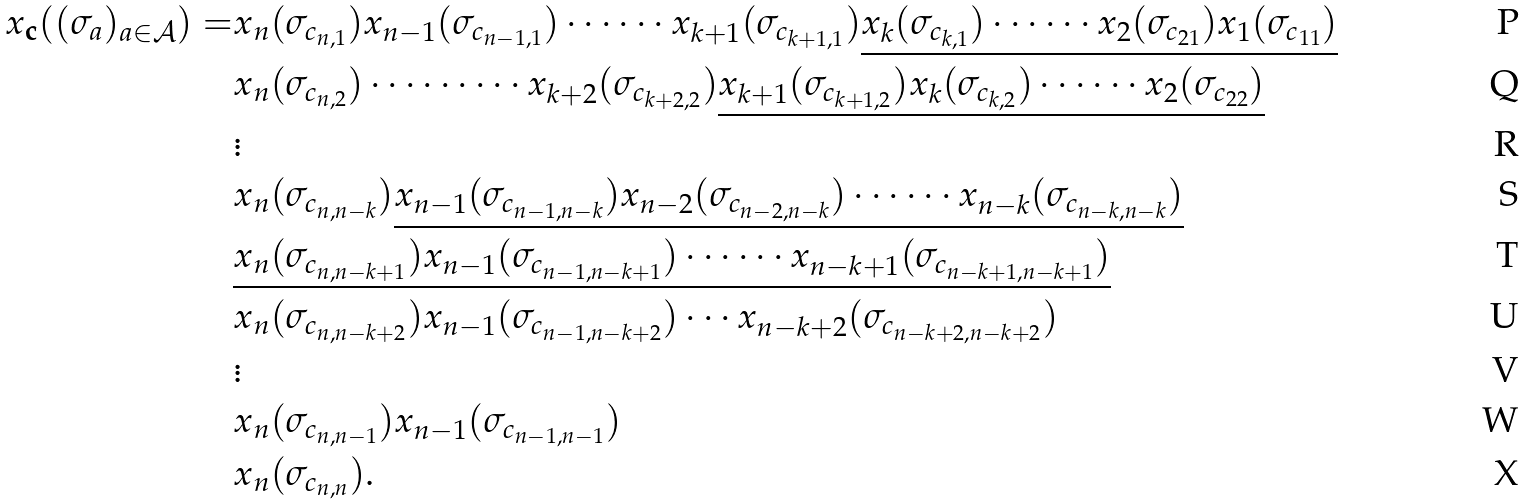<formula> <loc_0><loc_0><loc_500><loc_500>x _ { \mathbf c } ( ( \sigma _ { a } ) _ { a \in \mathcal { A } } ) = & x _ { n } ( \sigma _ { c _ { n , 1 } } ) x _ { n - 1 } ( \sigma _ { c _ { n - 1 , 1 } } ) \cdots \cdots x _ { k + 1 } ( \sigma _ { c _ { k + 1 , 1 } } ) \underline { x _ { k } ( \sigma _ { c _ { k , 1 } } ) \cdots \cdots x _ { 2 } ( \sigma _ { c _ { 2 1 } } ) x _ { 1 } ( \sigma _ { c _ { 1 1 } } ) } \\ & x _ { n } ( \sigma _ { c _ { n , 2 } } ) \cdots \cdots \cdots x _ { k + 2 } ( \sigma _ { c _ { k + 2 , 2 } } ) \underline { x _ { k + 1 } ( \sigma _ { c _ { k + 1 , 2 } } ) x _ { k } ( \sigma _ { c _ { k , 2 } } ) \cdots \cdots x _ { 2 } ( \sigma _ { c _ { 2 2 } } ) } \\ & \vdots \\ & x _ { n } ( \sigma _ { c _ { n , n - k } } ) \underline { x _ { n - 1 } ( \sigma _ { c _ { n - 1 , n - k } } ) x _ { n - 2 } ( \sigma _ { c _ { n - 2 , n - k } } ) \cdots \cdots x _ { n - k } ( \sigma _ { c _ { n - k , n - k } } ) } \\ & \underline { x _ { n } ( \sigma _ { c _ { n , n - k + 1 } } ) x _ { n - 1 } ( \sigma _ { c _ { n - 1 , n - k + 1 } } ) \cdots \cdots x _ { n - k + 1 } ( \sigma _ { c _ { n - k + 1 , n - k + 1 } } ) } \\ & x _ { n } ( \sigma _ { c _ { n , n - k + 2 } } ) x _ { n - 1 } ( \sigma _ { c _ { n - 1 , n - k + 2 } } ) \cdots x _ { n - k + 2 } ( \sigma _ { c _ { n - k + 2 , n - k + 2 } } ) \\ & \vdots \\ & x _ { n } ( \sigma _ { c _ { n , n - 1 } } ) x _ { n - 1 } ( \sigma _ { c _ { n - 1 , n - 1 } } ) \\ & x _ { n } ( \sigma _ { c _ { n , n } } ) .</formula> 